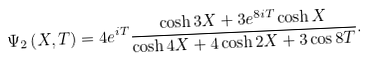Convert formula to latex. <formula><loc_0><loc_0><loc_500><loc_500>\Psi _ { 2 } \left ( X , T \right ) = 4 e ^ { i T } \frac { \cosh 3 X + 3 e ^ { 8 i T } \cosh X } { \cosh 4 X + 4 \cosh 2 X + 3 \cos 8 T } .</formula> 